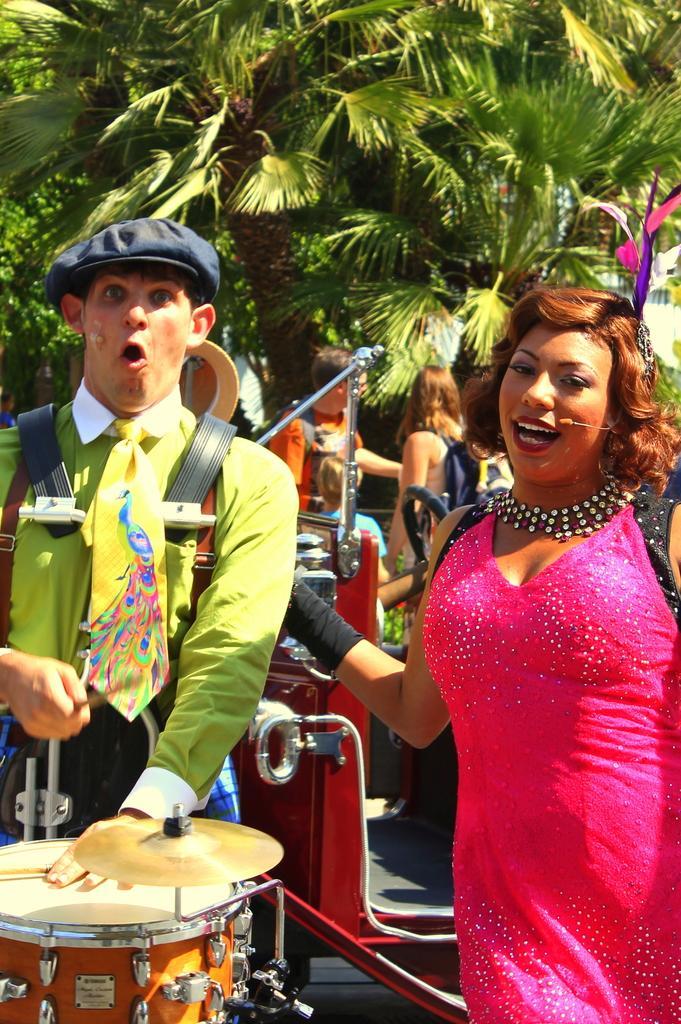In one or two sentences, can you explain what this image depicts? This is an outdoor picture. This picture is mainly highlighted with a woman and a man. This man is playing a drums. this is a cymbal. On the background we can see trees and also few persons. 